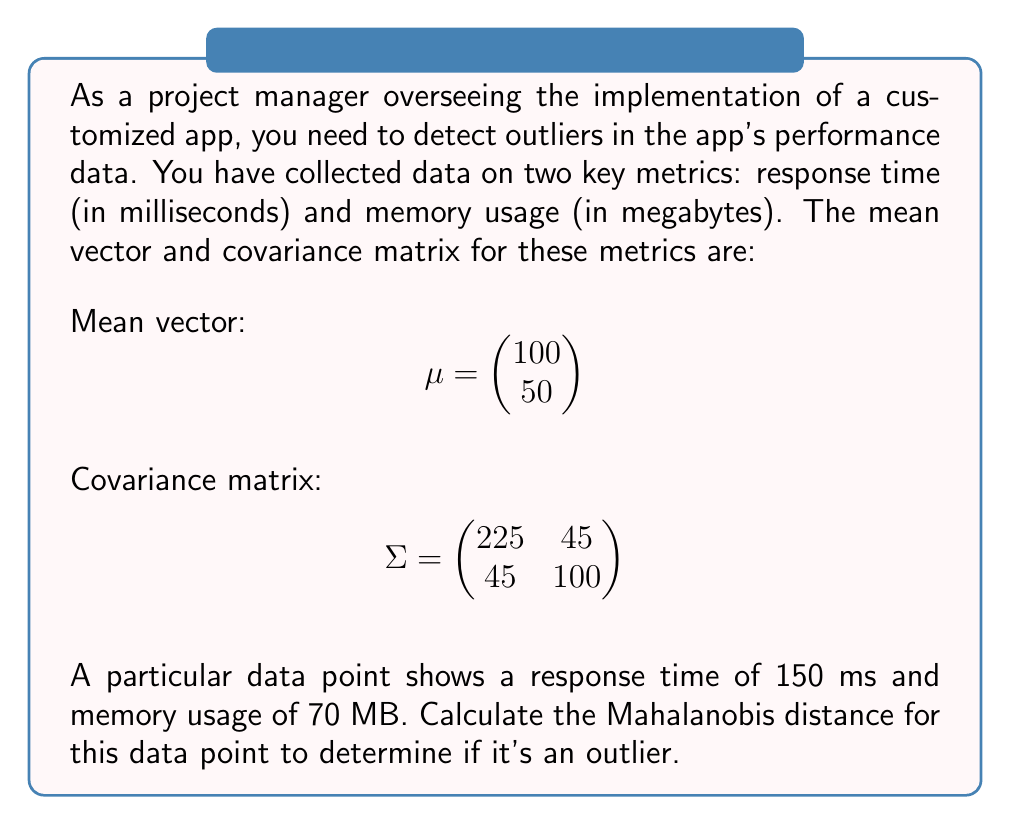Teach me how to tackle this problem. To calculate the Mahalanobis distance, we'll follow these steps:

1) The Mahalanobis distance is given by the formula:
   $$D = \sqrt{(x - \mu)^T \Sigma^{-1} (x - \mu)}$$
   where $x$ is the data point, $\mu$ is the mean vector, and $\Sigma$ is the covariance matrix.

2) First, let's calculate $(x - \mu)$:
   $$x - \mu = \begin{pmatrix} 150 \\ 70 \end{pmatrix} - \begin{pmatrix} 100 \\ 50 \end{pmatrix} = \begin{pmatrix} 50 \\ 20 \end{pmatrix}$$

3) Next, we need to find $\Sigma^{-1}$. The inverse of a 2x2 matrix $\begin{pmatrix} a & b \\ c & d \end{pmatrix}$ is:
   $$\frac{1}{ad-bc} \begin{pmatrix} d & -b \\ -c & a \end{pmatrix}$$

   For our covariance matrix:
   $$\Sigma^{-1} = \frac{1}{225(100) - 45^2} \begin{pmatrix} 100 & -45 \\ -45 & 225 \end{pmatrix} = \frac{1}{20025} \begin{pmatrix} 100 & -45 \\ -45 & 225 \end{pmatrix}$$

4) Now we can calculate $(x - \mu)^T \Sigma^{-1} (x - \mu)$:
   $$\begin{pmatrix} 50 & 20 \end{pmatrix} \frac{1}{20025} \begin{pmatrix} 100 & -45 \\ -45 & 225 \end{pmatrix} \begin{pmatrix} 50 \\ 20 \end{pmatrix}$$

5) Multiplying these matrices:
   $$\frac{1}{20025} (5000 - 2250 + 4500 - 2025) = \frac{5225}{20025} \approx 0.2609$$

6) Finally, we take the square root:
   $$D = \sqrt{0.2609} \approx 0.5108$$
Answer: $0.5108$ 